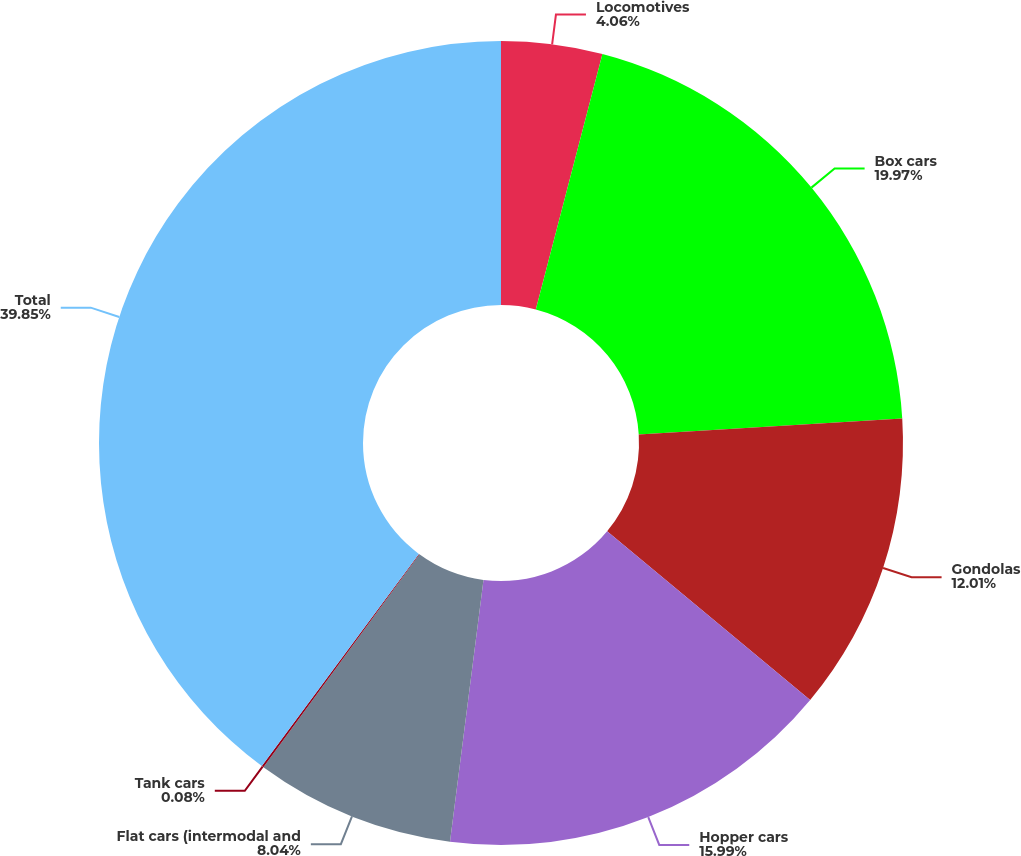Convert chart to OTSL. <chart><loc_0><loc_0><loc_500><loc_500><pie_chart><fcel>Locomotives<fcel>Box cars<fcel>Gondolas<fcel>Hopper cars<fcel>Flat cars (intermodal and<fcel>Tank cars<fcel>Total<nl><fcel>4.06%<fcel>19.97%<fcel>12.01%<fcel>15.99%<fcel>8.04%<fcel>0.08%<fcel>39.86%<nl></chart> 